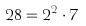Convert formula to latex. <formula><loc_0><loc_0><loc_500><loc_500>2 8 = 2 ^ { 2 } \cdot 7</formula> 